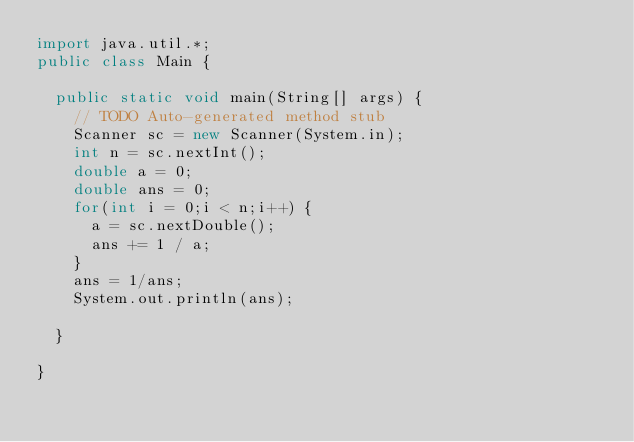Convert code to text. <code><loc_0><loc_0><loc_500><loc_500><_Java_>import java.util.*;
public class Main {

	public static void main(String[] args) {
		// TODO Auto-generated method stub
		Scanner sc = new Scanner(System.in);
		int n = sc.nextInt();
		double a = 0;
		double ans = 0;
		for(int i = 0;i < n;i++) {
			a = sc.nextDouble();
			ans += 1 / a;
		}
		ans = 1/ans;
		System.out.println(ans);
		
	}

}
</code> 